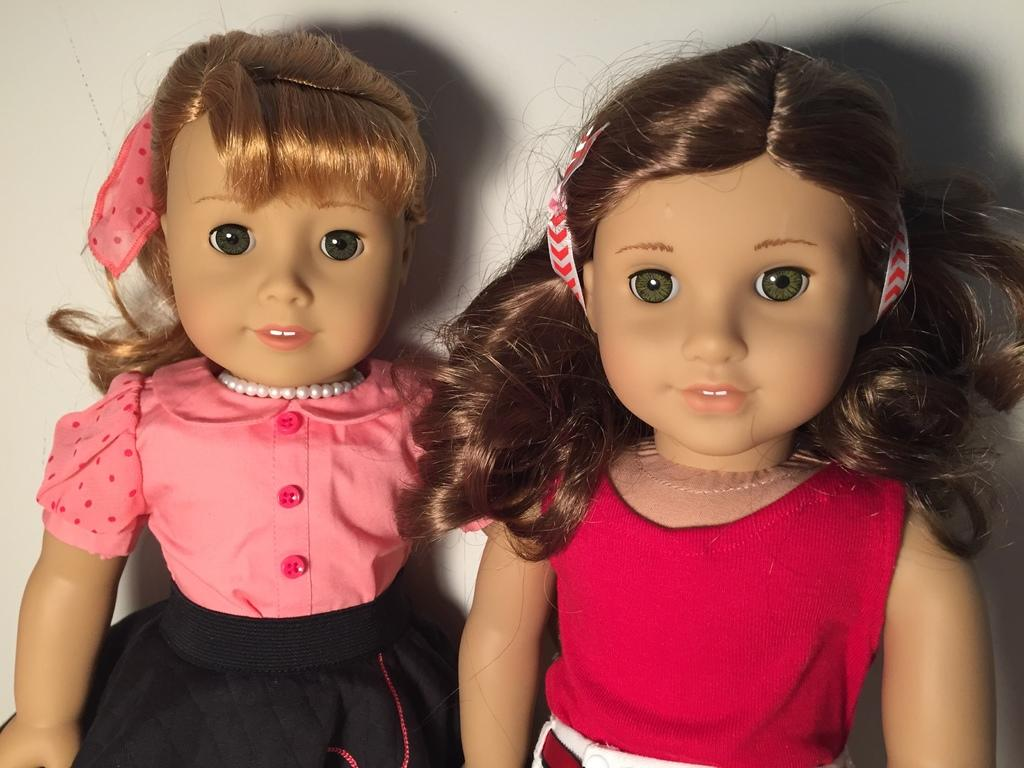What are the colors of the dresses on the toys in the image? One toy has a pink and black dress, and the other toy has a pink and white dress. What can be seen in the background of the image? There is a wall in the background of the image. What is visible on the wall in the image? The shadows of the toys are visible on the wall. What month is depicted on the stamp in the image? There is no stamp present in the image. How does the toy with the pink and black dress provide comfort to the other toy in the image? The toys do not interact with each other in the image, and there is no indication of comfort being provided. 